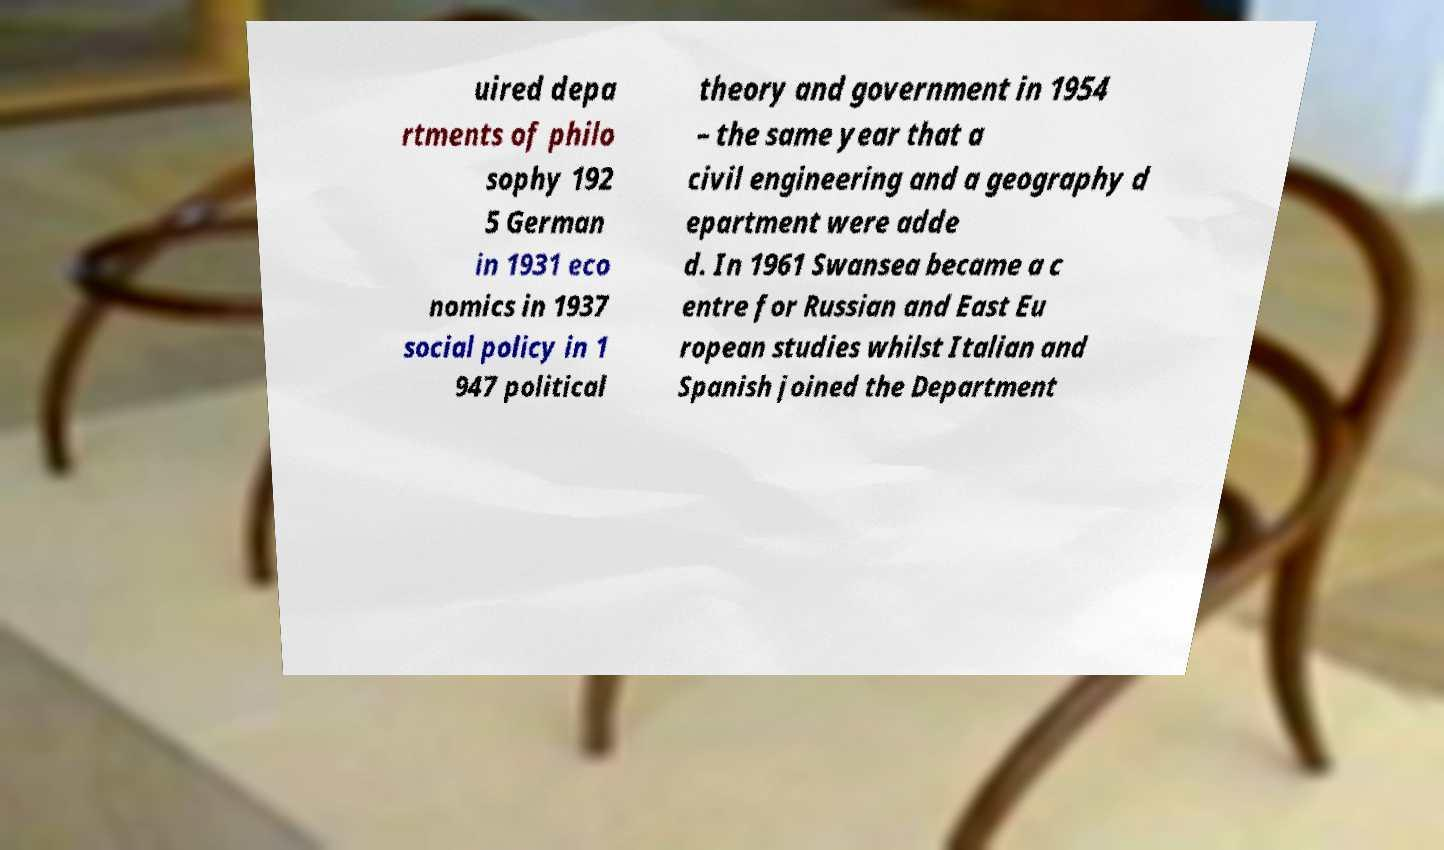There's text embedded in this image that I need extracted. Can you transcribe it verbatim? uired depa rtments of philo sophy 192 5 German in 1931 eco nomics in 1937 social policy in 1 947 political theory and government in 1954 – the same year that a civil engineering and a geography d epartment were adde d. In 1961 Swansea became a c entre for Russian and East Eu ropean studies whilst Italian and Spanish joined the Department 